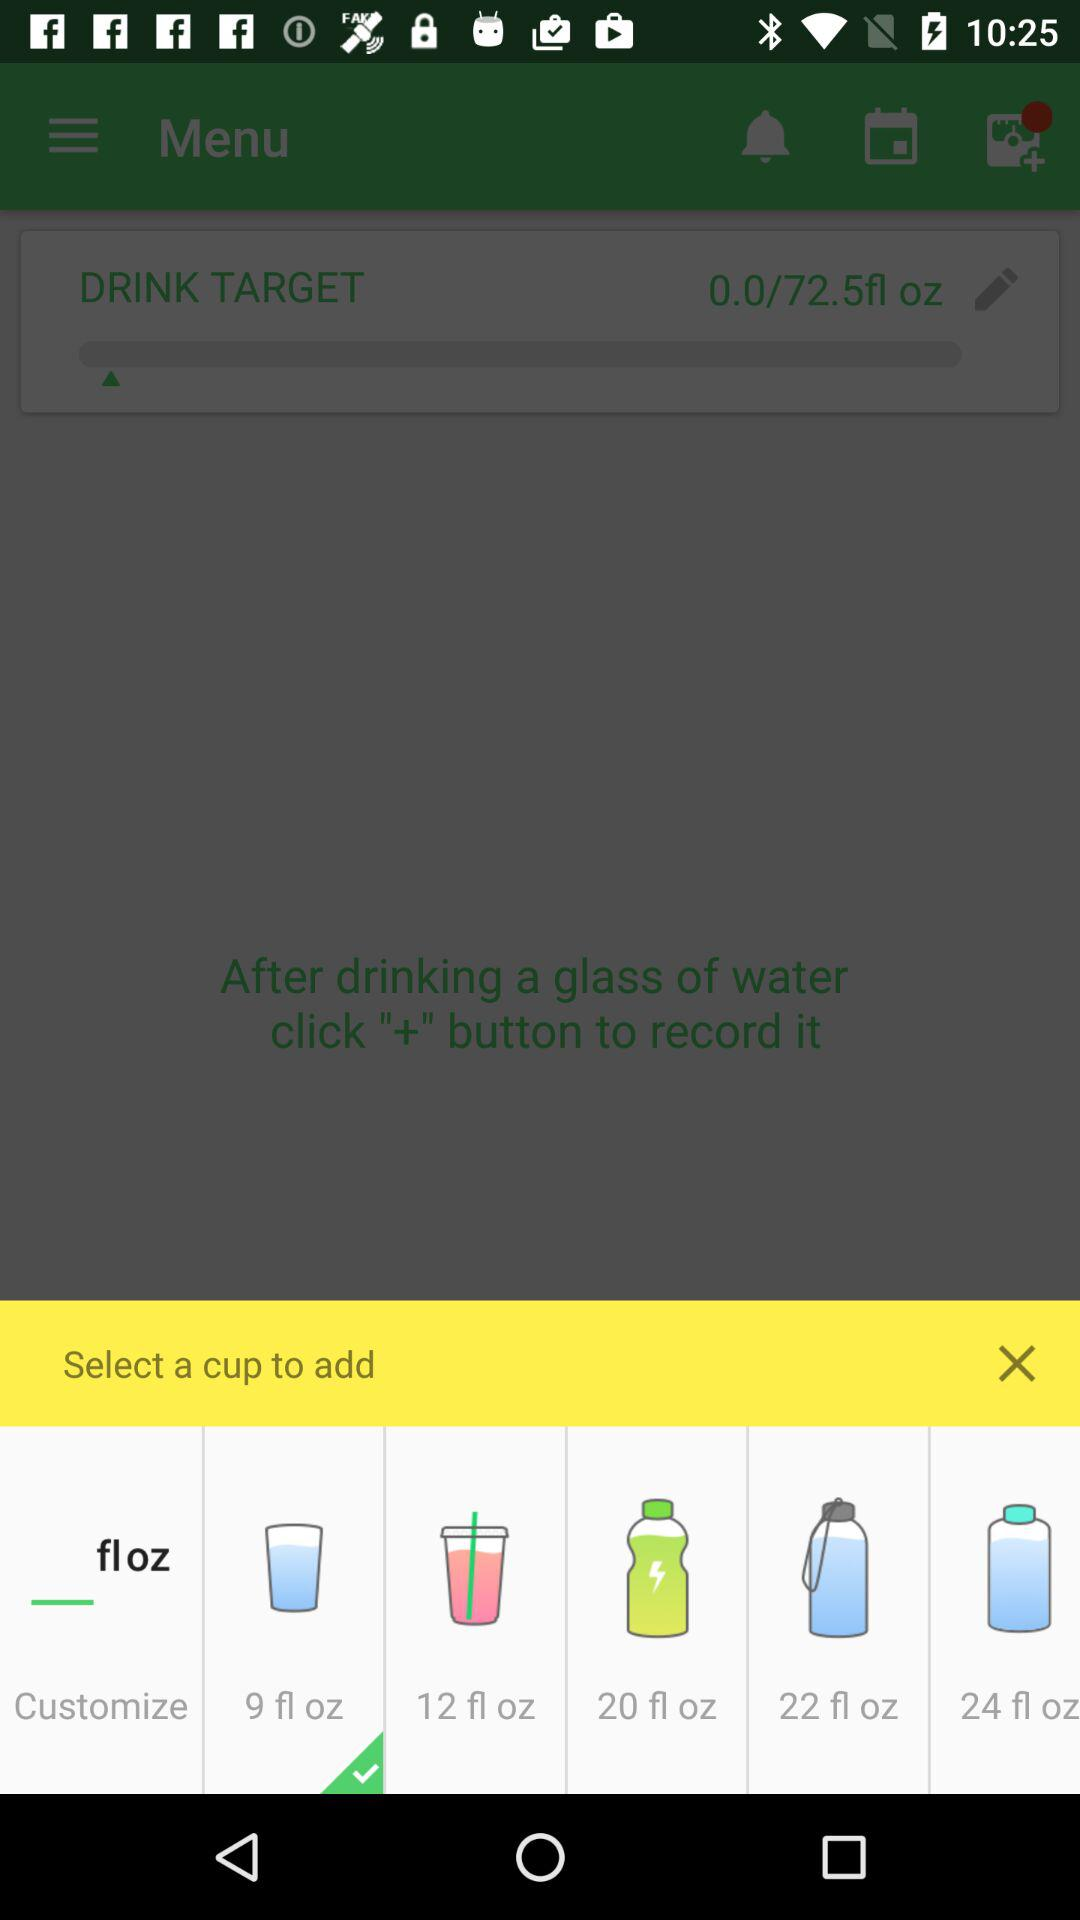How many ounces are in the largest cup?
Answer the question using a single word or phrase. 24 